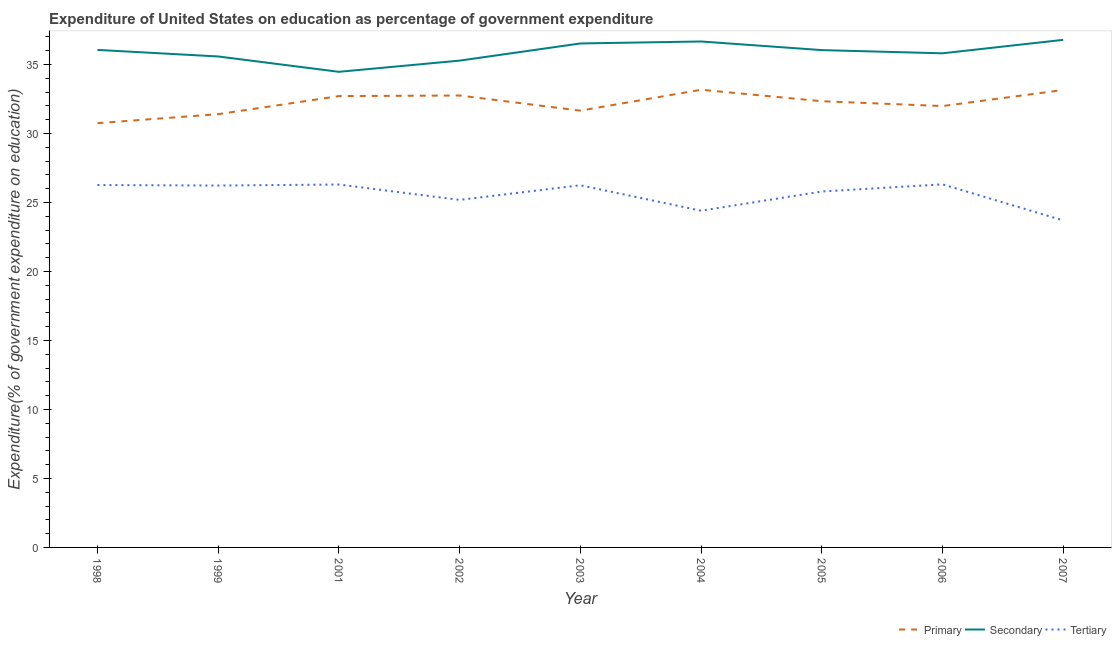How many different coloured lines are there?
Your response must be concise. 3. Is the number of lines equal to the number of legend labels?
Give a very brief answer. Yes. What is the expenditure on secondary education in 2002?
Offer a terse response. 35.28. Across all years, what is the maximum expenditure on tertiary education?
Keep it short and to the point. 26.31. Across all years, what is the minimum expenditure on tertiary education?
Offer a very short reply. 23.7. In which year was the expenditure on tertiary education maximum?
Offer a terse response. 2006. In which year was the expenditure on primary education minimum?
Provide a succinct answer. 1998. What is the total expenditure on primary education in the graph?
Keep it short and to the point. 289.87. What is the difference between the expenditure on secondary education in 1998 and that in 2005?
Offer a terse response. 0.01. What is the difference between the expenditure on secondary education in 1999 and the expenditure on tertiary education in 2004?
Keep it short and to the point. 11.18. What is the average expenditure on tertiary education per year?
Offer a very short reply. 25.6. In the year 2001, what is the difference between the expenditure on tertiary education and expenditure on secondary education?
Your answer should be very brief. -8.17. What is the ratio of the expenditure on tertiary education in 1998 to that in 1999?
Make the answer very short. 1. Is the expenditure on tertiary education in 2006 less than that in 2007?
Offer a very short reply. No. What is the difference between the highest and the second highest expenditure on tertiary education?
Offer a very short reply. 0.01. What is the difference between the highest and the lowest expenditure on secondary education?
Your answer should be very brief. 2.32. Is the sum of the expenditure on secondary education in 2001 and 2005 greater than the maximum expenditure on tertiary education across all years?
Provide a short and direct response. Yes. Is it the case that in every year, the sum of the expenditure on primary education and expenditure on secondary education is greater than the expenditure on tertiary education?
Offer a terse response. Yes. Does the expenditure on primary education monotonically increase over the years?
Offer a terse response. No. Is the expenditure on primary education strictly greater than the expenditure on secondary education over the years?
Your answer should be compact. No. How many years are there in the graph?
Your answer should be very brief. 9. Are the values on the major ticks of Y-axis written in scientific E-notation?
Provide a short and direct response. No. Does the graph contain grids?
Ensure brevity in your answer.  No. What is the title of the graph?
Keep it short and to the point. Expenditure of United States on education as percentage of government expenditure. What is the label or title of the X-axis?
Your answer should be very brief. Year. What is the label or title of the Y-axis?
Your response must be concise. Expenditure(% of government expenditure on education). What is the Expenditure(% of government expenditure on education) in Primary in 1998?
Ensure brevity in your answer.  30.74. What is the Expenditure(% of government expenditure on education) in Secondary in 1998?
Your answer should be compact. 36.05. What is the Expenditure(% of government expenditure on education) in Tertiary in 1998?
Provide a succinct answer. 26.26. What is the Expenditure(% of government expenditure on education) of Primary in 1999?
Offer a terse response. 31.39. What is the Expenditure(% of government expenditure on education) in Secondary in 1999?
Offer a terse response. 35.58. What is the Expenditure(% of government expenditure on education) of Tertiary in 1999?
Provide a succinct answer. 26.22. What is the Expenditure(% of government expenditure on education) in Primary in 2001?
Ensure brevity in your answer.  32.7. What is the Expenditure(% of government expenditure on education) in Secondary in 2001?
Make the answer very short. 34.46. What is the Expenditure(% of government expenditure on education) in Tertiary in 2001?
Offer a very short reply. 26.3. What is the Expenditure(% of government expenditure on education) of Primary in 2002?
Provide a succinct answer. 32.75. What is the Expenditure(% of government expenditure on education) in Secondary in 2002?
Make the answer very short. 35.28. What is the Expenditure(% of government expenditure on education) in Tertiary in 2002?
Offer a terse response. 25.18. What is the Expenditure(% of government expenditure on education) in Primary in 2003?
Offer a very short reply. 31.65. What is the Expenditure(% of government expenditure on education) in Secondary in 2003?
Provide a succinct answer. 36.52. What is the Expenditure(% of government expenditure on education) of Tertiary in 2003?
Make the answer very short. 26.25. What is the Expenditure(% of government expenditure on education) of Primary in 2004?
Keep it short and to the point. 33.16. What is the Expenditure(% of government expenditure on education) in Secondary in 2004?
Make the answer very short. 36.66. What is the Expenditure(% of government expenditure on education) of Tertiary in 2004?
Your answer should be compact. 24.4. What is the Expenditure(% of government expenditure on education) of Primary in 2005?
Make the answer very short. 32.33. What is the Expenditure(% of government expenditure on education) in Secondary in 2005?
Ensure brevity in your answer.  36.04. What is the Expenditure(% of government expenditure on education) of Tertiary in 2005?
Your response must be concise. 25.79. What is the Expenditure(% of government expenditure on education) in Primary in 2006?
Your answer should be compact. 31.98. What is the Expenditure(% of government expenditure on education) in Secondary in 2006?
Your answer should be very brief. 35.81. What is the Expenditure(% of government expenditure on education) of Tertiary in 2006?
Your response must be concise. 26.31. What is the Expenditure(% of government expenditure on education) in Primary in 2007?
Provide a short and direct response. 33.15. What is the Expenditure(% of government expenditure on education) of Secondary in 2007?
Offer a terse response. 36.78. What is the Expenditure(% of government expenditure on education) of Tertiary in 2007?
Provide a short and direct response. 23.7. Across all years, what is the maximum Expenditure(% of government expenditure on education) of Primary?
Keep it short and to the point. 33.16. Across all years, what is the maximum Expenditure(% of government expenditure on education) of Secondary?
Give a very brief answer. 36.78. Across all years, what is the maximum Expenditure(% of government expenditure on education) of Tertiary?
Offer a terse response. 26.31. Across all years, what is the minimum Expenditure(% of government expenditure on education) of Primary?
Give a very brief answer. 30.74. Across all years, what is the minimum Expenditure(% of government expenditure on education) in Secondary?
Make the answer very short. 34.46. Across all years, what is the minimum Expenditure(% of government expenditure on education) of Tertiary?
Ensure brevity in your answer.  23.7. What is the total Expenditure(% of government expenditure on education) in Primary in the graph?
Ensure brevity in your answer.  289.87. What is the total Expenditure(% of government expenditure on education) in Secondary in the graph?
Your answer should be compact. 323.17. What is the total Expenditure(% of government expenditure on education) in Tertiary in the graph?
Provide a short and direct response. 230.41. What is the difference between the Expenditure(% of government expenditure on education) in Primary in 1998 and that in 1999?
Ensure brevity in your answer.  -0.65. What is the difference between the Expenditure(% of government expenditure on education) of Secondary in 1998 and that in 1999?
Offer a terse response. 0.48. What is the difference between the Expenditure(% of government expenditure on education) in Tertiary in 1998 and that in 1999?
Your answer should be compact. 0.04. What is the difference between the Expenditure(% of government expenditure on education) in Primary in 1998 and that in 2001?
Your answer should be compact. -1.96. What is the difference between the Expenditure(% of government expenditure on education) in Secondary in 1998 and that in 2001?
Offer a terse response. 1.59. What is the difference between the Expenditure(% of government expenditure on education) in Tertiary in 1998 and that in 2001?
Make the answer very short. -0.04. What is the difference between the Expenditure(% of government expenditure on education) in Primary in 1998 and that in 2002?
Make the answer very short. -2. What is the difference between the Expenditure(% of government expenditure on education) of Secondary in 1998 and that in 2002?
Keep it short and to the point. 0.78. What is the difference between the Expenditure(% of government expenditure on education) of Tertiary in 1998 and that in 2002?
Keep it short and to the point. 1.08. What is the difference between the Expenditure(% of government expenditure on education) of Primary in 1998 and that in 2003?
Offer a terse response. -0.91. What is the difference between the Expenditure(% of government expenditure on education) of Secondary in 1998 and that in 2003?
Make the answer very short. -0.47. What is the difference between the Expenditure(% of government expenditure on education) in Tertiary in 1998 and that in 2003?
Ensure brevity in your answer.  0.02. What is the difference between the Expenditure(% of government expenditure on education) in Primary in 1998 and that in 2004?
Keep it short and to the point. -2.42. What is the difference between the Expenditure(% of government expenditure on education) in Secondary in 1998 and that in 2004?
Provide a short and direct response. -0.61. What is the difference between the Expenditure(% of government expenditure on education) of Tertiary in 1998 and that in 2004?
Keep it short and to the point. 1.86. What is the difference between the Expenditure(% of government expenditure on education) of Primary in 1998 and that in 2005?
Give a very brief answer. -1.59. What is the difference between the Expenditure(% of government expenditure on education) of Secondary in 1998 and that in 2005?
Provide a succinct answer. 0.01. What is the difference between the Expenditure(% of government expenditure on education) in Tertiary in 1998 and that in 2005?
Ensure brevity in your answer.  0.47. What is the difference between the Expenditure(% of government expenditure on education) in Primary in 1998 and that in 2006?
Keep it short and to the point. -1.24. What is the difference between the Expenditure(% of government expenditure on education) in Secondary in 1998 and that in 2006?
Give a very brief answer. 0.25. What is the difference between the Expenditure(% of government expenditure on education) in Tertiary in 1998 and that in 2006?
Your response must be concise. -0.05. What is the difference between the Expenditure(% of government expenditure on education) in Primary in 1998 and that in 2007?
Ensure brevity in your answer.  -2.4. What is the difference between the Expenditure(% of government expenditure on education) in Secondary in 1998 and that in 2007?
Offer a very short reply. -0.73. What is the difference between the Expenditure(% of government expenditure on education) in Tertiary in 1998 and that in 2007?
Your answer should be compact. 2.56. What is the difference between the Expenditure(% of government expenditure on education) of Primary in 1999 and that in 2001?
Provide a short and direct response. -1.31. What is the difference between the Expenditure(% of government expenditure on education) of Secondary in 1999 and that in 2001?
Offer a terse response. 1.11. What is the difference between the Expenditure(% of government expenditure on education) of Tertiary in 1999 and that in 2001?
Provide a short and direct response. -0.07. What is the difference between the Expenditure(% of government expenditure on education) in Primary in 1999 and that in 2002?
Your answer should be compact. -1.35. What is the difference between the Expenditure(% of government expenditure on education) of Secondary in 1999 and that in 2002?
Make the answer very short. 0.3. What is the difference between the Expenditure(% of government expenditure on education) in Tertiary in 1999 and that in 2002?
Keep it short and to the point. 1.04. What is the difference between the Expenditure(% of government expenditure on education) of Primary in 1999 and that in 2003?
Keep it short and to the point. -0.26. What is the difference between the Expenditure(% of government expenditure on education) of Secondary in 1999 and that in 2003?
Give a very brief answer. -0.94. What is the difference between the Expenditure(% of government expenditure on education) of Tertiary in 1999 and that in 2003?
Make the answer very short. -0.02. What is the difference between the Expenditure(% of government expenditure on education) in Primary in 1999 and that in 2004?
Provide a short and direct response. -1.77. What is the difference between the Expenditure(% of government expenditure on education) in Secondary in 1999 and that in 2004?
Offer a very short reply. -1.09. What is the difference between the Expenditure(% of government expenditure on education) of Tertiary in 1999 and that in 2004?
Your answer should be very brief. 1.82. What is the difference between the Expenditure(% of government expenditure on education) in Primary in 1999 and that in 2005?
Offer a very short reply. -0.94. What is the difference between the Expenditure(% of government expenditure on education) of Secondary in 1999 and that in 2005?
Your answer should be compact. -0.46. What is the difference between the Expenditure(% of government expenditure on education) of Tertiary in 1999 and that in 2005?
Keep it short and to the point. 0.43. What is the difference between the Expenditure(% of government expenditure on education) in Primary in 1999 and that in 2006?
Ensure brevity in your answer.  -0.59. What is the difference between the Expenditure(% of government expenditure on education) of Secondary in 1999 and that in 2006?
Your answer should be very brief. -0.23. What is the difference between the Expenditure(% of government expenditure on education) of Tertiary in 1999 and that in 2006?
Offer a very short reply. -0.09. What is the difference between the Expenditure(% of government expenditure on education) in Primary in 1999 and that in 2007?
Provide a succinct answer. -1.75. What is the difference between the Expenditure(% of government expenditure on education) of Secondary in 1999 and that in 2007?
Offer a terse response. -1.2. What is the difference between the Expenditure(% of government expenditure on education) in Tertiary in 1999 and that in 2007?
Keep it short and to the point. 2.53. What is the difference between the Expenditure(% of government expenditure on education) in Primary in 2001 and that in 2002?
Offer a terse response. -0.04. What is the difference between the Expenditure(% of government expenditure on education) of Secondary in 2001 and that in 2002?
Offer a terse response. -0.81. What is the difference between the Expenditure(% of government expenditure on education) in Tertiary in 2001 and that in 2002?
Keep it short and to the point. 1.11. What is the difference between the Expenditure(% of government expenditure on education) of Primary in 2001 and that in 2003?
Offer a terse response. 1.05. What is the difference between the Expenditure(% of government expenditure on education) in Secondary in 2001 and that in 2003?
Keep it short and to the point. -2.06. What is the difference between the Expenditure(% of government expenditure on education) in Tertiary in 2001 and that in 2003?
Your response must be concise. 0.05. What is the difference between the Expenditure(% of government expenditure on education) of Primary in 2001 and that in 2004?
Offer a very short reply. -0.46. What is the difference between the Expenditure(% of government expenditure on education) of Secondary in 2001 and that in 2004?
Give a very brief answer. -2.2. What is the difference between the Expenditure(% of government expenditure on education) of Tertiary in 2001 and that in 2004?
Provide a short and direct response. 1.9. What is the difference between the Expenditure(% of government expenditure on education) of Primary in 2001 and that in 2005?
Your answer should be compact. 0.37. What is the difference between the Expenditure(% of government expenditure on education) in Secondary in 2001 and that in 2005?
Keep it short and to the point. -1.57. What is the difference between the Expenditure(% of government expenditure on education) of Tertiary in 2001 and that in 2005?
Give a very brief answer. 0.51. What is the difference between the Expenditure(% of government expenditure on education) in Primary in 2001 and that in 2006?
Offer a terse response. 0.72. What is the difference between the Expenditure(% of government expenditure on education) in Secondary in 2001 and that in 2006?
Provide a short and direct response. -1.34. What is the difference between the Expenditure(% of government expenditure on education) in Tertiary in 2001 and that in 2006?
Your answer should be very brief. -0.01. What is the difference between the Expenditure(% of government expenditure on education) of Primary in 2001 and that in 2007?
Offer a very short reply. -0.44. What is the difference between the Expenditure(% of government expenditure on education) of Secondary in 2001 and that in 2007?
Your answer should be very brief. -2.32. What is the difference between the Expenditure(% of government expenditure on education) of Tertiary in 2001 and that in 2007?
Offer a terse response. 2.6. What is the difference between the Expenditure(% of government expenditure on education) of Primary in 2002 and that in 2003?
Offer a very short reply. 1.1. What is the difference between the Expenditure(% of government expenditure on education) of Secondary in 2002 and that in 2003?
Offer a terse response. -1.24. What is the difference between the Expenditure(% of government expenditure on education) in Tertiary in 2002 and that in 2003?
Offer a very short reply. -1.06. What is the difference between the Expenditure(% of government expenditure on education) in Primary in 2002 and that in 2004?
Offer a terse response. -0.42. What is the difference between the Expenditure(% of government expenditure on education) of Secondary in 2002 and that in 2004?
Your answer should be very brief. -1.39. What is the difference between the Expenditure(% of government expenditure on education) of Tertiary in 2002 and that in 2004?
Your response must be concise. 0.78. What is the difference between the Expenditure(% of government expenditure on education) in Primary in 2002 and that in 2005?
Your answer should be compact. 0.41. What is the difference between the Expenditure(% of government expenditure on education) of Secondary in 2002 and that in 2005?
Your answer should be compact. -0.76. What is the difference between the Expenditure(% of government expenditure on education) in Tertiary in 2002 and that in 2005?
Provide a short and direct response. -0.61. What is the difference between the Expenditure(% of government expenditure on education) in Primary in 2002 and that in 2006?
Your response must be concise. 0.76. What is the difference between the Expenditure(% of government expenditure on education) in Secondary in 2002 and that in 2006?
Provide a short and direct response. -0.53. What is the difference between the Expenditure(% of government expenditure on education) in Tertiary in 2002 and that in 2006?
Provide a short and direct response. -1.13. What is the difference between the Expenditure(% of government expenditure on education) of Primary in 2002 and that in 2007?
Provide a short and direct response. -0.4. What is the difference between the Expenditure(% of government expenditure on education) of Secondary in 2002 and that in 2007?
Provide a succinct answer. -1.5. What is the difference between the Expenditure(% of government expenditure on education) in Tertiary in 2002 and that in 2007?
Keep it short and to the point. 1.49. What is the difference between the Expenditure(% of government expenditure on education) in Primary in 2003 and that in 2004?
Offer a terse response. -1.51. What is the difference between the Expenditure(% of government expenditure on education) in Secondary in 2003 and that in 2004?
Offer a terse response. -0.14. What is the difference between the Expenditure(% of government expenditure on education) in Tertiary in 2003 and that in 2004?
Your answer should be compact. 1.85. What is the difference between the Expenditure(% of government expenditure on education) of Primary in 2003 and that in 2005?
Keep it short and to the point. -0.68. What is the difference between the Expenditure(% of government expenditure on education) of Secondary in 2003 and that in 2005?
Your response must be concise. 0.48. What is the difference between the Expenditure(% of government expenditure on education) of Tertiary in 2003 and that in 2005?
Your answer should be very brief. 0.45. What is the difference between the Expenditure(% of government expenditure on education) in Primary in 2003 and that in 2006?
Make the answer very short. -0.33. What is the difference between the Expenditure(% of government expenditure on education) of Secondary in 2003 and that in 2006?
Offer a terse response. 0.71. What is the difference between the Expenditure(% of government expenditure on education) of Tertiary in 2003 and that in 2006?
Your response must be concise. -0.07. What is the difference between the Expenditure(% of government expenditure on education) in Primary in 2003 and that in 2007?
Make the answer very short. -1.5. What is the difference between the Expenditure(% of government expenditure on education) in Secondary in 2003 and that in 2007?
Give a very brief answer. -0.26. What is the difference between the Expenditure(% of government expenditure on education) in Tertiary in 2003 and that in 2007?
Your answer should be compact. 2.55. What is the difference between the Expenditure(% of government expenditure on education) in Primary in 2004 and that in 2005?
Ensure brevity in your answer.  0.83. What is the difference between the Expenditure(% of government expenditure on education) of Secondary in 2004 and that in 2005?
Provide a succinct answer. 0.62. What is the difference between the Expenditure(% of government expenditure on education) in Tertiary in 2004 and that in 2005?
Give a very brief answer. -1.39. What is the difference between the Expenditure(% of government expenditure on education) in Primary in 2004 and that in 2006?
Your response must be concise. 1.18. What is the difference between the Expenditure(% of government expenditure on education) of Secondary in 2004 and that in 2006?
Make the answer very short. 0.86. What is the difference between the Expenditure(% of government expenditure on education) in Tertiary in 2004 and that in 2006?
Your answer should be very brief. -1.91. What is the difference between the Expenditure(% of government expenditure on education) in Primary in 2004 and that in 2007?
Your answer should be compact. 0.02. What is the difference between the Expenditure(% of government expenditure on education) in Secondary in 2004 and that in 2007?
Offer a very short reply. -0.12. What is the difference between the Expenditure(% of government expenditure on education) in Tertiary in 2004 and that in 2007?
Ensure brevity in your answer.  0.7. What is the difference between the Expenditure(% of government expenditure on education) in Primary in 2005 and that in 2006?
Offer a terse response. 0.35. What is the difference between the Expenditure(% of government expenditure on education) in Secondary in 2005 and that in 2006?
Offer a terse response. 0.23. What is the difference between the Expenditure(% of government expenditure on education) in Tertiary in 2005 and that in 2006?
Your answer should be compact. -0.52. What is the difference between the Expenditure(% of government expenditure on education) of Primary in 2005 and that in 2007?
Give a very brief answer. -0.81. What is the difference between the Expenditure(% of government expenditure on education) of Secondary in 2005 and that in 2007?
Provide a short and direct response. -0.74. What is the difference between the Expenditure(% of government expenditure on education) in Tertiary in 2005 and that in 2007?
Ensure brevity in your answer.  2.09. What is the difference between the Expenditure(% of government expenditure on education) in Primary in 2006 and that in 2007?
Give a very brief answer. -1.16. What is the difference between the Expenditure(% of government expenditure on education) of Secondary in 2006 and that in 2007?
Make the answer very short. -0.97. What is the difference between the Expenditure(% of government expenditure on education) of Tertiary in 2006 and that in 2007?
Keep it short and to the point. 2.61. What is the difference between the Expenditure(% of government expenditure on education) in Primary in 1998 and the Expenditure(% of government expenditure on education) in Secondary in 1999?
Your answer should be compact. -4.83. What is the difference between the Expenditure(% of government expenditure on education) of Primary in 1998 and the Expenditure(% of government expenditure on education) of Tertiary in 1999?
Your answer should be compact. 4.52. What is the difference between the Expenditure(% of government expenditure on education) of Secondary in 1998 and the Expenditure(% of government expenditure on education) of Tertiary in 1999?
Offer a terse response. 9.83. What is the difference between the Expenditure(% of government expenditure on education) in Primary in 1998 and the Expenditure(% of government expenditure on education) in Secondary in 2001?
Your answer should be compact. -3.72. What is the difference between the Expenditure(% of government expenditure on education) in Primary in 1998 and the Expenditure(% of government expenditure on education) in Tertiary in 2001?
Ensure brevity in your answer.  4.45. What is the difference between the Expenditure(% of government expenditure on education) in Secondary in 1998 and the Expenditure(% of government expenditure on education) in Tertiary in 2001?
Ensure brevity in your answer.  9.75. What is the difference between the Expenditure(% of government expenditure on education) in Primary in 1998 and the Expenditure(% of government expenditure on education) in Secondary in 2002?
Provide a succinct answer. -4.53. What is the difference between the Expenditure(% of government expenditure on education) of Primary in 1998 and the Expenditure(% of government expenditure on education) of Tertiary in 2002?
Provide a succinct answer. 5.56. What is the difference between the Expenditure(% of government expenditure on education) in Secondary in 1998 and the Expenditure(% of government expenditure on education) in Tertiary in 2002?
Offer a very short reply. 10.87. What is the difference between the Expenditure(% of government expenditure on education) of Primary in 1998 and the Expenditure(% of government expenditure on education) of Secondary in 2003?
Keep it short and to the point. -5.77. What is the difference between the Expenditure(% of government expenditure on education) in Primary in 1998 and the Expenditure(% of government expenditure on education) in Tertiary in 2003?
Give a very brief answer. 4.5. What is the difference between the Expenditure(% of government expenditure on education) in Secondary in 1998 and the Expenditure(% of government expenditure on education) in Tertiary in 2003?
Your answer should be very brief. 9.81. What is the difference between the Expenditure(% of government expenditure on education) of Primary in 1998 and the Expenditure(% of government expenditure on education) of Secondary in 2004?
Give a very brief answer. -5.92. What is the difference between the Expenditure(% of government expenditure on education) in Primary in 1998 and the Expenditure(% of government expenditure on education) in Tertiary in 2004?
Your answer should be compact. 6.35. What is the difference between the Expenditure(% of government expenditure on education) in Secondary in 1998 and the Expenditure(% of government expenditure on education) in Tertiary in 2004?
Give a very brief answer. 11.65. What is the difference between the Expenditure(% of government expenditure on education) in Primary in 1998 and the Expenditure(% of government expenditure on education) in Secondary in 2005?
Your answer should be compact. -5.29. What is the difference between the Expenditure(% of government expenditure on education) in Primary in 1998 and the Expenditure(% of government expenditure on education) in Tertiary in 2005?
Your answer should be compact. 4.95. What is the difference between the Expenditure(% of government expenditure on education) of Secondary in 1998 and the Expenditure(% of government expenditure on education) of Tertiary in 2005?
Offer a terse response. 10.26. What is the difference between the Expenditure(% of government expenditure on education) in Primary in 1998 and the Expenditure(% of government expenditure on education) in Secondary in 2006?
Provide a short and direct response. -5.06. What is the difference between the Expenditure(% of government expenditure on education) in Primary in 1998 and the Expenditure(% of government expenditure on education) in Tertiary in 2006?
Keep it short and to the point. 4.43. What is the difference between the Expenditure(% of government expenditure on education) in Secondary in 1998 and the Expenditure(% of government expenditure on education) in Tertiary in 2006?
Your answer should be compact. 9.74. What is the difference between the Expenditure(% of government expenditure on education) in Primary in 1998 and the Expenditure(% of government expenditure on education) in Secondary in 2007?
Your answer should be very brief. -6.04. What is the difference between the Expenditure(% of government expenditure on education) in Primary in 1998 and the Expenditure(% of government expenditure on education) in Tertiary in 2007?
Your answer should be compact. 7.05. What is the difference between the Expenditure(% of government expenditure on education) in Secondary in 1998 and the Expenditure(% of government expenditure on education) in Tertiary in 2007?
Offer a terse response. 12.36. What is the difference between the Expenditure(% of government expenditure on education) of Primary in 1999 and the Expenditure(% of government expenditure on education) of Secondary in 2001?
Ensure brevity in your answer.  -3.07. What is the difference between the Expenditure(% of government expenditure on education) in Primary in 1999 and the Expenditure(% of government expenditure on education) in Tertiary in 2001?
Provide a short and direct response. 5.1. What is the difference between the Expenditure(% of government expenditure on education) in Secondary in 1999 and the Expenditure(% of government expenditure on education) in Tertiary in 2001?
Offer a very short reply. 9.28. What is the difference between the Expenditure(% of government expenditure on education) of Primary in 1999 and the Expenditure(% of government expenditure on education) of Secondary in 2002?
Offer a terse response. -3.88. What is the difference between the Expenditure(% of government expenditure on education) of Primary in 1999 and the Expenditure(% of government expenditure on education) of Tertiary in 2002?
Offer a very short reply. 6.21. What is the difference between the Expenditure(% of government expenditure on education) of Secondary in 1999 and the Expenditure(% of government expenditure on education) of Tertiary in 2002?
Keep it short and to the point. 10.39. What is the difference between the Expenditure(% of government expenditure on education) in Primary in 1999 and the Expenditure(% of government expenditure on education) in Secondary in 2003?
Offer a very short reply. -5.12. What is the difference between the Expenditure(% of government expenditure on education) in Primary in 1999 and the Expenditure(% of government expenditure on education) in Tertiary in 2003?
Make the answer very short. 5.15. What is the difference between the Expenditure(% of government expenditure on education) in Secondary in 1999 and the Expenditure(% of government expenditure on education) in Tertiary in 2003?
Offer a very short reply. 9.33. What is the difference between the Expenditure(% of government expenditure on education) in Primary in 1999 and the Expenditure(% of government expenditure on education) in Secondary in 2004?
Offer a very short reply. -5.27. What is the difference between the Expenditure(% of government expenditure on education) of Primary in 1999 and the Expenditure(% of government expenditure on education) of Tertiary in 2004?
Your response must be concise. 7. What is the difference between the Expenditure(% of government expenditure on education) in Secondary in 1999 and the Expenditure(% of government expenditure on education) in Tertiary in 2004?
Keep it short and to the point. 11.18. What is the difference between the Expenditure(% of government expenditure on education) in Primary in 1999 and the Expenditure(% of government expenditure on education) in Secondary in 2005?
Your answer should be very brief. -4.64. What is the difference between the Expenditure(% of government expenditure on education) in Primary in 1999 and the Expenditure(% of government expenditure on education) in Tertiary in 2005?
Your answer should be very brief. 5.6. What is the difference between the Expenditure(% of government expenditure on education) in Secondary in 1999 and the Expenditure(% of government expenditure on education) in Tertiary in 2005?
Keep it short and to the point. 9.79. What is the difference between the Expenditure(% of government expenditure on education) of Primary in 1999 and the Expenditure(% of government expenditure on education) of Secondary in 2006?
Provide a succinct answer. -4.41. What is the difference between the Expenditure(% of government expenditure on education) of Primary in 1999 and the Expenditure(% of government expenditure on education) of Tertiary in 2006?
Provide a succinct answer. 5.08. What is the difference between the Expenditure(% of government expenditure on education) of Secondary in 1999 and the Expenditure(% of government expenditure on education) of Tertiary in 2006?
Keep it short and to the point. 9.27. What is the difference between the Expenditure(% of government expenditure on education) of Primary in 1999 and the Expenditure(% of government expenditure on education) of Secondary in 2007?
Offer a terse response. -5.39. What is the difference between the Expenditure(% of government expenditure on education) of Primary in 1999 and the Expenditure(% of government expenditure on education) of Tertiary in 2007?
Make the answer very short. 7.7. What is the difference between the Expenditure(% of government expenditure on education) of Secondary in 1999 and the Expenditure(% of government expenditure on education) of Tertiary in 2007?
Ensure brevity in your answer.  11.88. What is the difference between the Expenditure(% of government expenditure on education) in Primary in 2001 and the Expenditure(% of government expenditure on education) in Secondary in 2002?
Your response must be concise. -2.57. What is the difference between the Expenditure(% of government expenditure on education) of Primary in 2001 and the Expenditure(% of government expenditure on education) of Tertiary in 2002?
Offer a very short reply. 7.52. What is the difference between the Expenditure(% of government expenditure on education) in Secondary in 2001 and the Expenditure(% of government expenditure on education) in Tertiary in 2002?
Make the answer very short. 9.28. What is the difference between the Expenditure(% of government expenditure on education) of Primary in 2001 and the Expenditure(% of government expenditure on education) of Secondary in 2003?
Offer a very short reply. -3.81. What is the difference between the Expenditure(% of government expenditure on education) of Primary in 2001 and the Expenditure(% of government expenditure on education) of Tertiary in 2003?
Give a very brief answer. 6.46. What is the difference between the Expenditure(% of government expenditure on education) of Secondary in 2001 and the Expenditure(% of government expenditure on education) of Tertiary in 2003?
Provide a succinct answer. 8.22. What is the difference between the Expenditure(% of government expenditure on education) of Primary in 2001 and the Expenditure(% of government expenditure on education) of Secondary in 2004?
Your answer should be very brief. -3.96. What is the difference between the Expenditure(% of government expenditure on education) of Primary in 2001 and the Expenditure(% of government expenditure on education) of Tertiary in 2004?
Keep it short and to the point. 8.31. What is the difference between the Expenditure(% of government expenditure on education) in Secondary in 2001 and the Expenditure(% of government expenditure on education) in Tertiary in 2004?
Offer a very short reply. 10.06. What is the difference between the Expenditure(% of government expenditure on education) of Primary in 2001 and the Expenditure(% of government expenditure on education) of Secondary in 2005?
Make the answer very short. -3.33. What is the difference between the Expenditure(% of government expenditure on education) in Primary in 2001 and the Expenditure(% of government expenditure on education) in Tertiary in 2005?
Provide a short and direct response. 6.91. What is the difference between the Expenditure(% of government expenditure on education) of Secondary in 2001 and the Expenditure(% of government expenditure on education) of Tertiary in 2005?
Ensure brevity in your answer.  8.67. What is the difference between the Expenditure(% of government expenditure on education) in Primary in 2001 and the Expenditure(% of government expenditure on education) in Secondary in 2006?
Offer a very short reply. -3.1. What is the difference between the Expenditure(% of government expenditure on education) of Primary in 2001 and the Expenditure(% of government expenditure on education) of Tertiary in 2006?
Provide a succinct answer. 6.39. What is the difference between the Expenditure(% of government expenditure on education) of Secondary in 2001 and the Expenditure(% of government expenditure on education) of Tertiary in 2006?
Provide a succinct answer. 8.15. What is the difference between the Expenditure(% of government expenditure on education) in Primary in 2001 and the Expenditure(% of government expenditure on education) in Secondary in 2007?
Offer a terse response. -4.08. What is the difference between the Expenditure(% of government expenditure on education) in Primary in 2001 and the Expenditure(% of government expenditure on education) in Tertiary in 2007?
Offer a very short reply. 9.01. What is the difference between the Expenditure(% of government expenditure on education) in Secondary in 2001 and the Expenditure(% of government expenditure on education) in Tertiary in 2007?
Your response must be concise. 10.77. What is the difference between the Expenditure(% of government expenditure on education) of Primary in 2002 and the Expenditure(% of government expenditure on education) of Secondary in 2003?
Keep it short and to the point. -3.77. What is the difference between the Expenditure(% of government expenditure on education) of Primary in 2002 and the Expenditure(% of government expenditure on education) of Tertiary in 2003?
Offer a very short reply. 6.5. What is the difference between the Expenditure(% of government expenditure on education) of Secondary in 2002 and the Expenditure(% of government expenditure on education) of Tertiary in 2003?
Ensure brevity in your answer.  9.03. What is the difference between the Expenditure(% of government expenditure on education) in Primary in 2002 and the Expenditure(% of government expenditure on education) in Secondary in 2004?
Provide a succinct answer. -3.92. What is the difference between the Expenditure(% of government expenditure on education) in Primary in 2002 and the Expenditure(% of government expenditure on education) in Tertiary in 2004?
Ensure brevity in your answer.  8.35. What is the difference between the Expenditure(% of government expenditure on education) of Secondary in 2002 and the Expenditure(% of government expenditure on education) of Tertiary in 2004?
Make the answer very short. 10.88. What is the difference between the Expenditure(% of government expenditure on education) of Primary in 2002 and the Expenditure(% of government expenditure on education) of Secondary in 2005?
Provide a succinct answer. -3.29. What is the difference between the Expenditure(% of government expenditure on education) of Primary in 2002 and the Expenditure(% of government expenditure on education) of Tertiary in 2005?
Provide a short and direct response. 6.96. What is the difference between the Expenditure(% of government expenditure on education) of Secondary in 2002 and the Expenditure(% of government expenditure on education) of Tertiary in 2005?
Make the answer very short. 9.48. What is the difference between the Expenditure(% of government expenditure on education) in Primary in 2002 and the Expenditure(% of government expenditure on education) in Secondary in 2006?
Your response must be concise. -3.06. What is the difference between the Expenditure(% of government expenditure on education) of Primary in 2002 and the Expenditure(% of government expenditure on education) of Tertiary in 2006?
Offer a very short reply. 6.44. What is the difference between the Expenditure(% of government expenditure on education) of Secondary in 2002 and the Expenditure(% of government expenditure on education) of Tertiary in 2006?
Make the answer very short. 8.97. What is the difference between the Expenditure(% of government expenditure on education) of Primary in 2002 and the Expenditure(% of government expenditure on education) of Secondary in 2007?
Provide a succinct answer. -4.03. What is the difference between the Expenditure(% of government expenditure on education) of Primary in 2002 and the Expenditure(% of government expenditure on education) of Tertiary in 2007?
Keep it short and to the point. 9.05. What is the difference between the Expenditure(% of government expenditure on education) in Secondary in 2002 and the Expenditure(% of government expenditure on education) in Tertiary in 2007?
Offer a very short reply. 11.58. What is the difference between the Expenditure(% of government expenditure on education) in Primary in 2003 and the Expenditure(% of government expenditure on education) in Secondary in 2004?
Your response must be concise. -5.01. What is the difference between the Expenditure(% of government expenditure on education) in Primary in 2003 and the Expenditure(% of government expenditure on education) in Tertiary in 2004?
Provide a succinct answer. 7.25. What is the difference between the Expenditure(% of government expenditure on education) of Secondary in 2003 and the Expenditure(% of government expenditure on education) of Tertiary in 2004?
Offer a very short reply. 12.12. What is the difference between the Expenditure(% of government expenditure on education) of Primary in 2003 and the Expenditure(% of government expenditure on education) of Secondary in 2005?
Make the answer very short. -4.39. What is the difference between the Expenditure(% of government expenditure on education) in Primary in 2003 and the Expenditure(% of government expenditure on education) in Tertiary in 2005?
Make the answer very short. 5.86. What is the difference between the Expenditure(% of government expenditure on education) of Secondary in 2003 and the Expenditure(% of government expenditure on education) of Tertiary in 2005?
Provide a succinct answer. 10.73. What is the difference between the Expenditure(% of government expenditure on education) in Primary in 2003 and the Expenditure(% of government expenditure on education) in Secondary in 2006?
Your answer should be compact. -4.16. What is the difference between the Expenditure(% of government expenditure on education) of Primary in 2003 and the Expenditure(% of government expenditure on education) of Tertiary in 2006?
Provide a succinct answer. 5.34. What is the difference between the Expenditure(% of government expenditure on education) in Secondary in 2003 and the Expenditure(% of government expenditure on education) in Tertiary in 2006?
Offer a terse response. 10.21. What is the difference between the Expenditure(% of government expenditure on education) in Primary in 2003 and the Expenditure(% of government expenditure on education) in Secondary in 2007?
Your answer should be very brief. -5.13. What is the difference between the Expenditure(% of government expenditure on education) of Primary in 2003 and the Expenditure(% of government expenditure on education) of Tertiary in 2007?
Make the answer very short. 7.95. What is the difference between the Expenditure(% of government expenditure on education) in Secondary in 2003 and the Expenditure(% of government expenditure on education) in Tertiary in 2007?
Ensure brevity in your answer.  12.82. What is the difference between the Expenditure(% of government expenditure on education) in Primary in 2004 and the Expenditure(% of government expenditure on education) in Secondary in 2005?
Ensure brevity in your answer.  -2.87. What is the difference between the Expenditure(% of government expenditure on education) of Primary in 2004 and the Expenditure(% of government expenditure on education) of Tertiary in 2005?
Offer a terse response. 7.37. What is the difference between the Expenditure(% of government expenditure on education) of Secondary in 2004 and the Expenditure(% of government expenditure on education) of Tertiary in 2005?
Ensure brevity in your answer.  10.87. What is the difference between the Expenditure(% of government expenditure on education) of Primary in 2004 and the Expenditure(% of government expenditure on education) of Secondary in 2006?
Your answer should be very brief. -2.64. What is the difference between the Expenditure(% of government expenditure on education) in Primary in 2004 and the Expenditure(% of government expenditure on education) in Tertiary in 2006?
Your response must be concise. 6.85. What is the difference between the Expenditure(% of government expenditure on education) in Secondary in 2004 and the Expenditure(% of government expenditure on education) in Tertiary in 2006?
Ensure brevity in your answer.  10.35. What is the difference between the Expenditure(% of government expenditure on education) of Primary in 2004 and the Expenditure(% of government expenditure on education) of Secondary in 2007?
Keep it short and to the point. -3.62. What is the difference between the Expenditure(% of government expenditure on education) of Primary in 2004 and the Expenditure(% of government expenditure on education) of Tertiary in 2007?
Provide a short and direct response. 9.47. What is the difference between the Expenditure(% of government expenditure on education) in Secondary in 2004 and the Expenditure(% of government expenditure on education) in Tertiary in 2007?
Give a very brief answer. 12.96. What is the difference between the Expenditure(% of government expenditure on education) of Primary in 2005 and the Expenditure(% of government expenditure on education) of Secondary in 2006?
Provide a short and direct response. -3.47. What is the difference between the Expenditure(% of government expenditure on education) in Primary in 2005 and the Expenditure(% of government expenditure on education) in Tertiary in 2006?
Your response must be concise. 6.02. What is the difference between the Expenditure(% of government expenditure on education) of Secondary in 2005 and the Expenditure(% of government expenditure on education) of Tertiary in 2006?
Provide a short and direct response. 9.73. What is the difference between the Expenditure(% of government expenditure on education) in Primary in 2005 and the Expenditure(% of government expenditure on education) in Secondary in 2007?
Offer a terse response. -4.45. What is the difference between the Expenditure(% of government expenditure on education) in Primary in 2005 and the Expenditure(% of government expenditure on education) in Tertiary in 2007?
Provide a succinct answer. 8.64. What is the difference between the Expenditure(% of government expenditure on education) of Secondary in 2005 and the Expenditure(% of government expenditure on education) of Tertiary in 2007?
Ensure brevity in your answer.  12.34. What is the difference between the Expenditure(% of government expenditure on education) of Primary in 2006 and the Expenditure(% of government expenditure on education) of Secondary in 2007?
Keep it short and to the point. -4.8. What is the difference between the Expenditure(% of government expenditure on education) in Primary in 2006 and the Expenditure(% of government expenditure on education) in Tertiary in 2007?
Offer a very short reply. 8.29. What is the difference between the Expenditure(% of government expenditure on education) in Secondary in 2006 and the Expenditure(% of government expenditure on education) in Tertiary in 2007?
Your answer should be compact. 12.11. What is the average Expenditure(% of government expenditure on education) in Primary per year?
Offer a terse response. 32.21. What is the average Expenditure(% of government expenditure on education) in Secondary per year?
Keep it short and to the point. 35.91. What is the average Expenditure(% of government expenditure on education) of Tertiary per year?
Offer a terse response. 25.6. In the year 1998, what is the difference between the Expenditure(% of government expenditure on education) in Primary and Expenditure(% of government expenditure on education) in Secondary?
Provide a short and direct response. -5.31. In the year 1998, what is the difference between the Expenditure(% of government expenditure on education) in Primary and Expenditure(% of government expenditure on education) in Tertiary?
Give a very brief answer. 4.48. In the year 1998, what is the difference between the Expenditure(% of government expenditure on education) of Secondary and Expenditure(% of government expenditure on education) of Tertiary?
Keep it short and to the point. 9.79. In the year 1999, what is the difference between the Expenditure(% of government expenditure on education) of Primary and Expenditure(% of government expenditure on education) of Secondary?
Offer a terse response. -4.18. In the year 1999, what is the difference between the Expenditure(% of government expenditure on education) in Primary and Expenditure(% of government expenditure on education) in Tertiary?
Your response must be concise. 5.17. In the year 1999, what is the difference between the Expenditure(% of government expenditure on education) in Secondary and Expenditure(% of government expenditure on education) in Tertiary?
Offer a very short reply. 9.35. In the year 2001, what is the difference between the Expenditure(% of government expenditure on education) in Primary and Expenditure(% of government expenditure on education) in Secondary?
Offer a very short reply. -1.76. In the year 2001, what is the difference between the Expenditure(% of government expenditure on education) in Primary and Expenditure(% of government expenditure on education) in Tertiary?
Provide a succinct answer. 6.41. In the year 2001, what is the difference between the Expenditure(% of government expenditure on education) in Secondary and Expenditure(% of government expenditure on education) in Tertiary?
Give a very brief answer. 8.17. In the year 2002, what is the difference between the Expenditure(% of government expenditure on education) of Primary and Expenditure(% of government expenditure on education) of Secondary?
Your response must be concise. -2.53. In the year 2002, what is the difference between the Expenditure(% of government expenditure on education) in Primary and Expenditure(% of government expenditure on education) in Tertiary?
Offer a very short reply. 7.56. In the year 2002, what is the difference between the Expenditure(% of government expenditure on education) in Secondary and Expenditure(% of government expenditure on education) in Tertiary?
Keep it short and to the point. 10.09. In the year 2003, what is the difference between the Expenditure(% of government expenditure on education) in Primary and Expenditure(% of government expenditure on education) in Secondary?
Provide a succinct answer. -4.87. In the year 2003, what is the difference between the Expenditure(% of government expenditure on education) in Primary and Expenditure(% of government expenditure on education) in Tertiary?
Keep it short and to the point. 5.4. In the year 2003, what is the difference between the Expenditure(% of government expenditure on education) in Secondary and Expenditure(% of government expenditure on education) in Tertiary?
Give a very brief answer. 10.27. In the year 2004, what is the difference between the Expenditure(% of government expenditure on education) of Primary and Expenditure(% of government expenditure on education) of Secondary?
Provide a short and direct response. -3.5. In the year 2004, what is the difference between the Expenditure(% of government expenditure on education) of Primary and Expenditure(% of government expenditure on education) of Tertiary?
Provide a succinct answer. 8.77. In the year 2004, what is the difference between the Expenditure(% of government expenditure on education) in Secondary and Expenditure(% of government expenditure on education) in Tertiary?
Offer a terse response. 12.26. In the year 2005, what is the difference between the Expenditure(% of government expenditure on education) of Primary and Expenditure(% of government expenditure on education) of Secondary?
Your answer should be compact. -3.7. In the year 2005, what is the difference between the Expenditure(% of government expenditure on education) in Primary and Expenditure(% of government expenditure on education) in Tertiary?
Give a very brief answer. 6.54. In the year 2005, what is the difference between the Expenditure(% of government expenditure on education) in Secondary and Expenditure(% of government expenditure on education) in Tertiary?
Your answer should be very brief. 10.25. In the year 2006, what is the difference between the Expenditure(% of government expenditure on education) in Primary and Expenditure(% of government expenditure on education) in Secondary?
Your response must be concise. -3.82. In the year 2006, what is the difference between the Expenditure(% of government expenditure on education) of Primary and Expenditure(% of government expenditure on education) of Tertiary?
Keep it short and to the point. 5.67. In the year 2006, what is the difference between the Expenditure(% of government expenditure on education) of Secondary and Expenditure(% of government expenditure on education) of Tertiary?
Offer a very short reply. 9.5. In the year 2007, what is the difference between the Expenditure(% of government expenditure on education) in Primary and Expenditure(% of government expenditure on education) in Secondary?
Provide a short and direct response. -3.63. In the year 2007, what is the difference between the Expenditure(% of government expenditure on education) of Primary and Expenditure(% of government expenditure on education) of Tertiary?
Ensure brevity in your answer.  9.45. In the year 2007, what is the difference between the Expenditure(% of government expenditure on education) in Secondary and Expenditure(% of government expenditure on education) in Tertiary?
Your answer should be compact. 13.08. What is the ratio of the Expenditure(% of government expenditure on education) in Primary in 1998 to that in 1999?
Offer a very short reply. 0.98. What is the ratio of the Expenditure(% of government expenditure on education) in Secondary in 1998 to that in 1999?
Offer a very short reply. 1.01. What is the ratio of the Expenditure(% of government expenditure on education) of Primary in 1998 to that in 2001?
Your response must be concise. 0.94. What is the ratio of the Expenditure(% of government expenditure on education) in Secondary in 1998 to that in 2001?
Your response must be concise. 1.05. What is the ratio of the Expenditure(% of government expenditure on education) in Tertiary in 1998 to that in 2001?
Your answer should be compact. 1. What is the ratio of the Expenditure(% of government expenditure on education) of Primary in 1998 to that in 2002?
Ensure brevity in your answer.  0.94. What is the ratio of the Expenditure(% of government expenditure on education) of Secondary in 1998 to that in 2002?
Make the answer very short. 1.02. What is the ratio of the Expenditure(% of government expenditure on education) of Tertiary in 1998 to that in 2002?
Provide a succinct answer. 1.04. What is the ratio of the Expenditure(% of government expenditure on education) in Primary in 1998 to that in 2003?
Offer a terse response. 0.97. What is the ratio of the Expenditure(% of government expenditure on education) in Secondary in 1998 to that in 2003?
Ensure brevity in your answer.  0.99. What is the ratio of the Expenditure(% of government expenditure on education) of Tertiary in 1998 to that in 2003?
Your response must be concise. 1. What is the ratio of the Expenditure(% of government expenditure on education) in Primary in 1998 to that in 2004?
Your answer should be compact. 0.93. What is the ratio of the Expenditure(% of government expenditure on education) in Secondary in 1998 to that in 2004?
Ensure brevity in your answer.  0.98. What is the ratio of the Expenditure(% of government expenditure on education) in Tertiary in 1998 to that in 2004?
Provide a short and direct response. 1.08. What is the ratio of the Expenditure(% of government expenditure on education) in Primary in 1998 to that in 2005?
Keep it short and to the point. 0.95. What is the ratio of the Expenditure(% of government expenditure on education) of Secondary in 1998 to that in 2005?
Offer a terse response. 1. What is the ratio of the Expenditure(% of government expenditure on education) of Tertiary in 1998 to that in 2005?
Your answer should be very brief. 1.02. What is the ratio of the Expenditure(% of government expenditure on education) in Primary in 1998 to that in 2006?
Offer a terse response. 0.96. What is the ratio of the Expenditure(% of government expenditure on education) in Secondary in 1998 to that in 2006?
Provide a succinct answer. 1.01. What is the ratio of the Expenditure(% of government expenditure on education) in Primary in 1998 to that in 2007?
Offer a very short reply. 0.93. What is the ratio of the Expenditure(% of government expenditure on education) of Secondary in 1998 to that in 2007?
Provide a succinct answer. 0.98. What is the ratio of the Expenditure(% of government expenditure on education) of Tertiary in 1998 to that in 2007?
Give a very brief answer. 1.11. What is the ratio of the Expenditure(% of government expenditure on education) of Primary in 1999 to that in 2001?
Ensure brevity in your answer.  0.96. What is the ratio of the Expenditure(% of government expenditure on education) of Secondary in 1999 to that in 2001?
Offer a terse response. 1.03. What is the ratio of the Expenditure(% of government expenditure on education) of Primary in 1999 to that in 2002?
Provide a succinct answer. 0.96. What is the ratio of the Expenditure(% of government expenditure on education) in Secondary in 1999 to that in 2002?
Make the answer very short. 1.01. What is the ratio of the Expenditure(% of government expenditure on education) in Tertiary in 1999 to that in 2002?
Provide a short and direct response. 1.04. What is the ratio of the Expenditure(% of government expenditure on education) of Primary in 1999 to that in 2003?
Keep it short and to the point. 0.99. What is the ratio of the Expenditure(% of government expenditure on education) of Secondary in 1999 to that in 2003?
Your answer should be very brief. 0.97. What is the ratio of the Expenditure(% of government expenditure on education) of Primary in 1999 to that in 2004?
Your response must be concise. 0.95. What is the ratio of the Expenditure(% of government expenditure on education) in Secondary in 1999 to that in 2004?
Your response must be concise. 0.97. What is the ratio of the Expenditure(% of government expenditure on education) of Tertiary in 1999 to that in 2004?
Your answer should be compact. 1.07. What is the ratio of the Expenditure(% of government expenditure on education) in Primary in 1999 to that in 2005?
Give a very brief answer. 0.97. What is the ratio of the Expenditure(% of government expenditure on education) in Secondary in 1999 to that in 2005?
Provide a short and direct response. 0.99. What is the ratio of the Expenditure(% of government expenditure on education) in Tertiary in 1999 to that in 2005?
Keep it short and to the point. 1.02. What is the ratio of the Expenditure(% of government expenditure on education) of Primary in 1999 to that in 2006?
Offer a terse response. 0.98. What is the ratio of the Expenditure(% of government expenditure on education) in Tertiary in 1999 to that in 2006?
Ensure brevity in your answer.  1. What is the ratio of the Expenditure(% of government expenditure on education) in Primary in 1999 to that in 2007?
Your answer should be very brief. 0.95. What is the ratio of the Expenditure(% of government expenditure on education) of Secondary in 1999 to that in 2007?
Offer a terse response. 0.97. What is the ratio of the Expenditure(% of government expenditure on education) of Tertiary in 1999 to that in 2007?
Your response must be concise. 1.11. What is the ratio of the Expenditure(% of government expenditure on education) in Primary in 2001 to that in 2002?
Provide a short and direct response. 1. What is the ratio of the Expenditure(% of government expenditure on education) of Tertiary in 2001 to that in 2002?
Provide a succinct answer. 1.04. What is the ratio of the Expenditure(% of government expenditure on education) in Secondary in 2001 to that in 2003?
Provide a succinct answer. 0.94. What is the ratio of the Expenditure(% of government expenditure on education) in Tertiary in 2001 to that in 2003?
Provide a succinct answer. 1. What is the ratio of the Expenditure(% of government expenditure on education) in Primary in 2001 to that in 2004?
Provide a short and direct response. 0.99. What is the ratio of the Expenditure(% of government expenditure on education) of Tertiary in 2001 to that in 2004?
Make the answer very short. 1.08. What is the ratio of the Expenditure(% of government expenditure on education) in Primary in 2001 to that in 2005?
Give a very brief answer. 1.01. What is the ratio of the Expenditure(% of government expenditure on education) of Secondary in 2001 to that in 2005?
Give a very brief answer. 0.96. What is the ratio of the Expenditure(% of government expenditure on education) of Tertiary in 2001 to that in 2005?
Offer a very short reply. 1.02. What is the ratio of the Expenditure(% of government expenditure on education) of Primary in 2001 to that in 2006?
Give a very brief answer. 1.02. What is the ratio of the Expenditure(% of government expenditure on education) of Secondary in 2001 to that in 2006?
Your answer should be very brief. 0.96. What is the ratio of the Expenditure(% of government expenditure on education) in Tertiary in 2001 to that in 2006?
Offer a very short reply. 1. What is the ratio of the Expenditure(% of government expenditure on education) of Primary in 2001 to that in 2007?
Your answer should be very brief. 0.99. What is the ratio of the Expenditure(% of government expenditure on education) of Secondary in 2001 to that in 2007?
Provide a succinct answer. 0.94. What is the ratio of the Expenditure(% of government expenditure on education) of Tertiary in 2001 to that in 2007?
Offer a terse response. 1.11. What is the ratio of the Expenditure(% of government expenditure on education) of Primary in 2002 to that in 2003?
Give a very brief answer. 1.03. What is the ratio of the Expenditure(% of government expenditure on education) in Secondary in 2002 to that in 2003?
Give a very brief answer. 0.97. What is the ratio of the Expenditure(% of government expenditure on education) of Tertiary in 2002 to that in 2003?
Offer a very short reply. 0.96. What is the ratio of the Expenditure(% of government expenditure on education) of Primary in 2002 to that in 2004?
Ensure brevity in your answer.  0.99. What is the ratio of the Expenditure(% of government expenditure on education) of Secondary in 2002 to that in 2004?
Your response must be concise. 0.96. What is the ratio of the Expenditure(% of government expenditure on education) in Tertiary in 2002 to that in 2004?
Offer a very short reply. 1.03. What is the ratio of the Expenditure(% of government expenditure on education) in Primary in 2002 to that in 2005?
Provide a succinct answer. 1.01. What is the ratio of the Expenditure(% of government expenditure on education) of Secondary in 2002 to that in 2005?
Your answer should be compact. 0.98. What is the ratio of the Expenditure(% of government expenditure on education) in Tertiary in 2002 to that in 2005?
Give a very brief answer. 0.98. What is the ratio of the Expenditure(% of government expenditure on education) of Primary in 2002 to that in 2006?
Your answer should be very brief. 1.02. What is the ratio of the Expenditure(% of government expenditure on education) of Secondary in 2002 to that in 2006?
Your answer should be compact. 0.99. What is the ratio of the Expenditure(% of government expenditure on education) of Tertiary in 2002 to that in 2006?
Your answer should be very brief. 0.96. What is the ratio of the Expenditure(% of government expenditure on education) of Primary in 2002 to that in 2007?
Your answer should be compact. 0.99. What is the ratio of the Expenditure(% of government expenditure on education) in Secondary in 2002 to that in 2007?
Keep it short and to the point. 0.96. What is the ratio of the Expenditure(% of government expenditure on education) in Tertiary in 2002 to that in 2007?
Provide a succinct answer. 1.06. What is the ratio of the Expenditure(% of government expenditure on education) in Primary in 2003 to that in 2004?
Your answer should be compact. 0.95. What is the ratio of the Expenditure(% of government expenditure on education) in Secondary in 2003 to that in 2004?
Give a very brief answer. 1. What is the ratio of the Expenditure(% of government expenditure on education) of Tertiary in 2003 to that in 2004?
Provide a short and direct response. 1.08. What is the ratio of the Expenditure(% of government expenditure on education) in Primary in 2003 to that in 2005?
Ensure brevity in your answer.  0.98. What is the ratio of the Expenditure(% of government expenditure on education) of Secondary in 2003 to that in 2005?
Your answer should be very brief. 1.01. What is the ratio of the Expenditure(% of government expenditure on education) in Tertiary in 2003 to that in 2005?
Offer a terse response. 1.02. What is the ratio of the Expenditure(% of government expenditure on education) of Primary in 2003 to that in 2006?
Your response must be concise. 0.99. What is the ratio of the Expenditure(% of government expenditure on education) of Secondary in 2003 to that in 2006?
Offer a terse response. 1.02. What is the ratio of the Expenditure(% of government expenditure on education) of Primary in 2003 to that in 2007?
Give a very brief answer. 0.95. What is the ratio of the Expenditure(% of government expenditure on education) of Secondary in 2003 to that in 2007?
Give a very brief answer. 0.99. What is the ratio of the Expenditure(% of government expenditure on education) in Tertiary in 2003 to that in 2007?
Ensure brevity in your answer.  1.11. What is the ratio of the Expenditure(% of government expenditure on education) in Primary in 2004 to that in 2005?
Your response must be concise. 1.03. What is the ratio of the Expenditure(% of government expenditure on education) in Secondary in 2004 to that in 2005?
Your answer should be very brief. 1.02. What is the ratio of the Expenditure(% of government expenditure on education) in Tertiary in 2004 to that in 2005?
Give a very brief answer. 0.95. What is the ratio of the Expenditure(% of government expenditure on education) in Secondary in 2004 to that in 2006?
Keep it short and to the point. 1.02. What is the ratio of the Expenditure(% of government expenditure on education) of Tertiary in 2004 to that in 2006?
Your answer should be very brief. 0.93. What is the ratio of the Expenditure(% of government expenditure on education) of Primary in 2004 to that in 2007?
Provide a succinct answer. 1. What is the ratio of the Expenditure(% of government expenditure on education) of Secondary in 2004 to that in 2007?
Keep it short and to the point. 1. What is the ratio of the Expenditure(% of government expenditure on education) in Tertiary in 2004 to that in 2007?
Keep it short and to the point. 1.03. What is the ratio of the Expenditure(% of government expenditure on education) in Tertiary in 2005 to that in 2006?
Offer a terse response. 0.98. What is the ratio of the Expenditure(% of government expenditure on education) in Primary in 2005 to that in 2007?
Keep it short and to the point. 0.98. What is the ratio of the Expenditure(% of government expenditure on education) of Secondary in 2005 to that in 2007?
Make the answer very short. 0.98. What is the ratio of the Expenditure(% of government expenditure on education) of Tertiary in 2005 to that in 2007?
Offer a terse response. 1.09. What is the ratio of the Expenditure(% of government expenditure on education) in Primary in 2006 to that in 2007?
Give a very brief answer. 0.96. What is the ratio of the Expenditure(% of government expenditure on education) of Secondary in 2006 to that in 2007?
Your response must be concise. 0.97. What is the ratio of the Expenditure(% of government expenditure on education) of Tertiary in 2006 to that in 2007?
Offer a very short reply. 1.11. What is the difference between the highest and the second highest Expenditure(% of government expenditure on education) in Primary?
Offer a terse response. 0.02. What is the difference between the highest and the second highest Expenditure(% of government expenditure on education) of Secondary?
Ensure brevity in your answer.  0.12. What is the difference between the highest and the second highest Expenditure(% of government expenditure on education) of Tertiary?
Provide a succinct answer. 0.01. What is the difference between the highest and the lowest Expenditure(% of government expenditure on education) of Primary?
Ensure brevity in your answer.  2.42. What is the difference between the highest and the lowest Expenditure(% of government expenditure on education) of Secondary?
Give a very brief answer. 2.32. What is the difference between the highest and the lowest Expenditure(% of government expenditure on education) of Tertiary?
Your response must be concise. 2.61. 